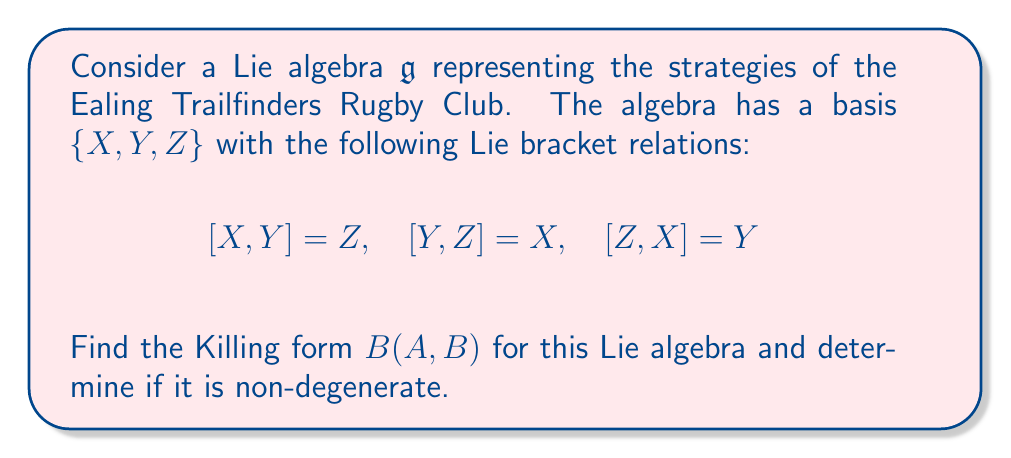Can you answer this question? To find the Killing form for this Lie algebra, we need to follow these steps:

1) The Killing form is defined as $B(A,B) = \text{tr}(\text{ad}_A \circ \text{ad}_B)$, where $\text{ad}_A$ is the adjoint representation of $A$.

2) First, let's calculate the adjoint representations for each basis element:

   For $X$: $\text{ad}_X(Y) = [X,Y] = Z$, $\text{ad}_X(Z) = [X,Z] = -Y$, $\text{ad}_X(X) = 0$
   
   $$\text{ad}_X = \begin{pmatrix} 0 & 0 & 0 \\ 0 & 0 & -1 \\ 0 & 1 & 0 \end{pmatrix}$$

   Similarly, 
   
   $$\text{ad}_Y = \begin{pmatrix} 0 & 0 & 1 \\ 0 & 0 & 0 \\ -1 & 0 & 0 \end{pmatrix}$$
   
   $$\text{ad}_Z = \begin{pmatrix} 0 & -1 & 0 \\ 1 & 0 & 0 \\ 0 & 0 & 0 \end{pmatrix}$$

3) Now, let's calculate $B(X,X)$, $B(Y,Y)$, and $B(Z,Z)$:

   $B(X,X) = \text{tr}(\text{ad}_X \circ \text{ad}_X) = \text{tr}(\begin{pmatrix} 0 & 0 & 0 \\ 0 & -1 & 0 \\ 0 & 0 & -1 \end{pmatrix}) = -2$

   Similarly, $B(Y,Y) = B(Z,Z) = -2$

4) For the off-diagonal elements:

   $B(X,Y) = \text{tr}(\text{ad}_X \circ \text{ad}_Y) = \text{tr}(\begin{pmatrix} 0 & 0 & 0 \\ 0 & 0 & 0 \\ 0 & 0 & 0 \end{pmatrix}) = 0$

   Similarly, $B(X,Z) = B(Y,Z) = 0$

5) Therefore, the Killing form matrix is:

   $$B = \begin{pmatrix} -2 & 0 & 0 \\ 0 & -2 & 0 \\ 0 & 0 & -2 \end{pmatrix}$$

6) This matrix is diagonal with non-zero entries, so it is non-degenerate.
Answer: The Killing form for the given Lie algebra is:

$$B = \begin{pmatrix} -2 & 0 & 0 \\ 0 & -2 & 0 \\ 0 & 0 & -2 \end{pmatrix}$$

It is non-degenerate. 